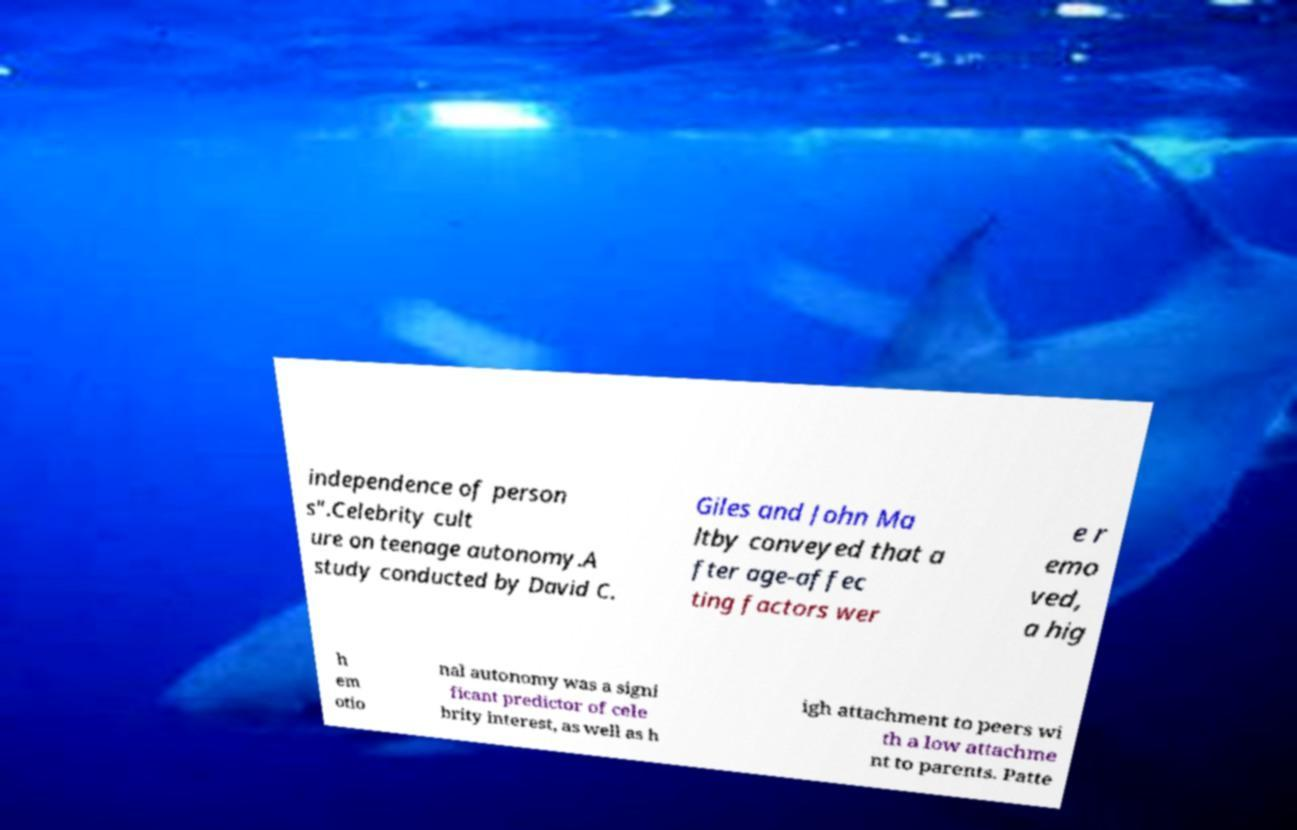Can you read and provide the text displayed in the image?This photo seems to have some interesting text. Can you extract and type it out for me? independence of person s".Celebrity cult ure on teenage autonomy.A study conducted by David C. Giles and John Ma ltby conveyed that a fter age-affec ting factors wer e r emo ved, a hig h em otio nal autonomy was a signi ficant predictor of cele brity interest, as well as h igh attachment to peers wi th a low attachme nt to parents. Patte 